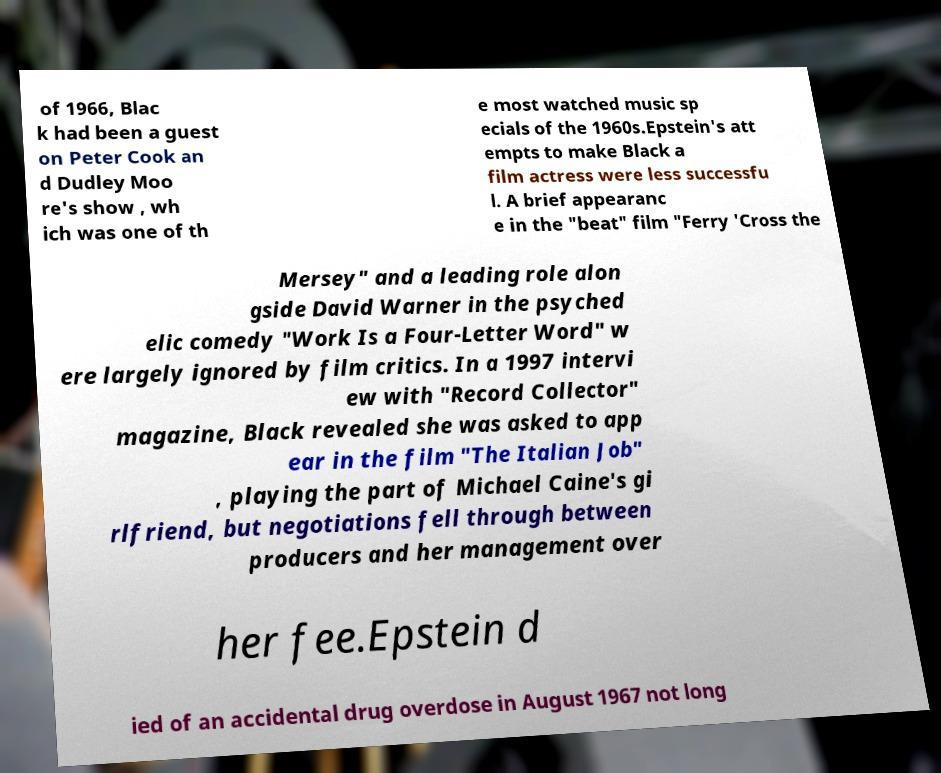Can you accurately transcribe the text from the provided image for me? of 1966, Blac k had been a guest on Peter Cook an d Dudley Moo re's show , wh ich was one of th e most watched music sp ecials of the 1960s.Epstein's att empts to make Black a film actress were less successfu l. A brief appearanc e in the "beat" film "Ferry 'Cross the Mersey" and a leading role alon gside David Warner in the psyched elic comedy "Work Is a Four-Letter Word" w ere largely ignored by film critics. In a 1997 intervi ew with "Record Collector" magazine, Black revealed she was asked to app ear in the film "The Italian Job" , playing the part of Michael Caine's gi rlfriend, but negotiations fell through between producers and her management over her fee.Epstein d ied of an accidental drug overdose in August 1967 not long 